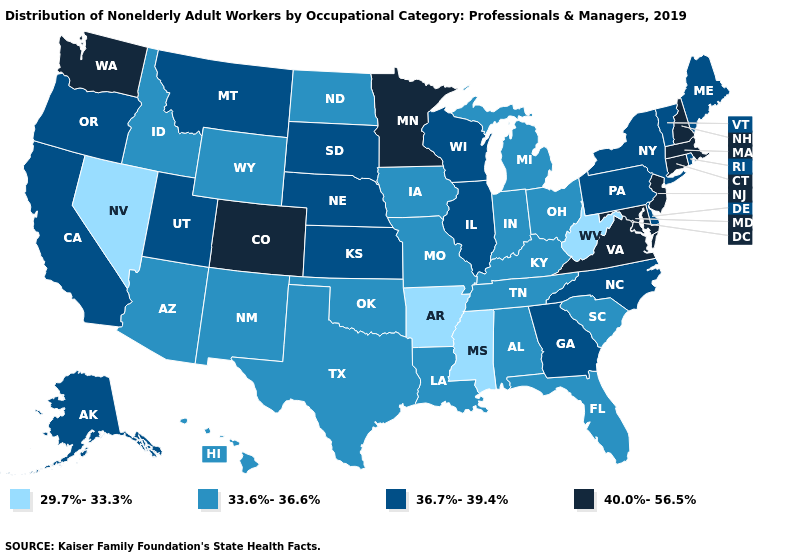Does Massachusetts have the lowest value in the USA?
Short answer required. No. What is the value of Hawaii?
Keep it brief. 33.6%-36.6%. Name the states that have a value in the range 33.6%-36.6%?
Concise answer only. Alabama, Arizona, Florida, Hawaii, Idaho, Indiana, Iowa, Kentucky, Louisiana, Michigan, Missouri, New Mexico, North Dakota, Ohio, Oklahoma, South Carolina, Tennessee, Texas, Wyoming. Name the states that have a value in the range 36.7%-39.4%?
Answer briefly. Alaska, California, Delaware, Georgia, Illinois, Kansas, Maine, Montana, Nebraska, New York, North Carolina, Oregon, Pennsylvania, Rhode Island, South Dakota, Utah, Vermont, Wisconsin. Does the first symbol in the legend represent the smallest category?
Keep it brief. Yes. What is the value of Mississippi?
Write a very short answer. 29.7%-33.3%. Among the states that border Alabama , does Mississippi have the highest value?
Be succinct. No. Does the map have missing data?
Be succinct. No. What is the value of Maine?
Be succinct. 36.7%-39.4%. What is the value of Texas?
Write a very short answer. 33.6%-36.6%. Which states hav the highest value in the Northeast?
Concise answer only. Connecticut, Massachusetts, New Hampshire, New Jersey. What is the value of Texas?
Quick response, please. 33.6%-36.6%. What is the value of Kansas?
Answer briefly. 36.7%-39.4%. Does Wyoming have the highest value in the West?
Keep it brief. No. Does Iowa have the same value as Tennessee?
Give a very brief answer. Yes. 